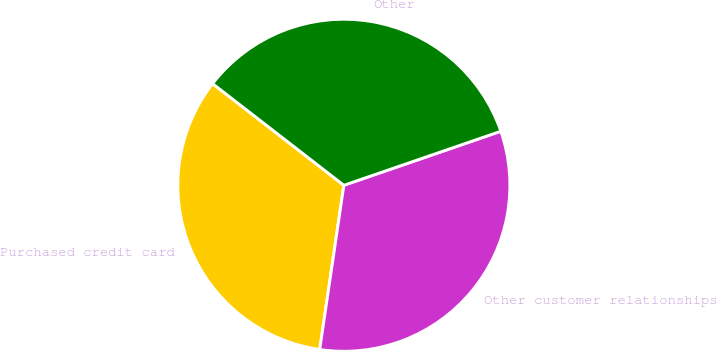<chart> <loc_0><loc_0><loc_500><loc_500><pie_chart><fcel>Purchased credit card<fcel>Other customer relationships<fcel>Other<nl><fcel>33.16%<fcel>32.6%<fcel>34.24%<nl></chart> 